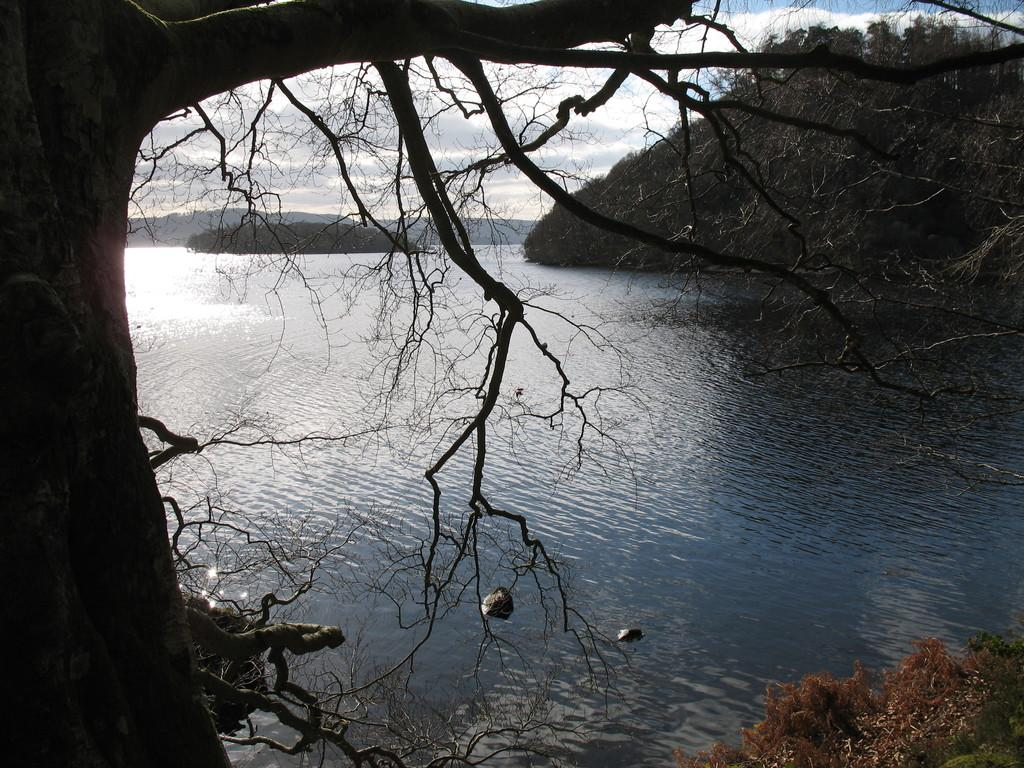What type of plant can be seen in the image? There is a tree in the image. What natural element is present in the image? There is water in the image. What type of vegetation is visible in the image? There is grass in the image. What part of the tree is visible in the image? There are leaves in the image. What can be seen in the background of the image? There are trees and hills in the background of the image. What is visible in the sky in the image? There are clouds in the sky. Can you see a nail sticking out of the tree in the image? There is no nail visible in the image; it features a tree with leaves and a background of hills and clouds. 